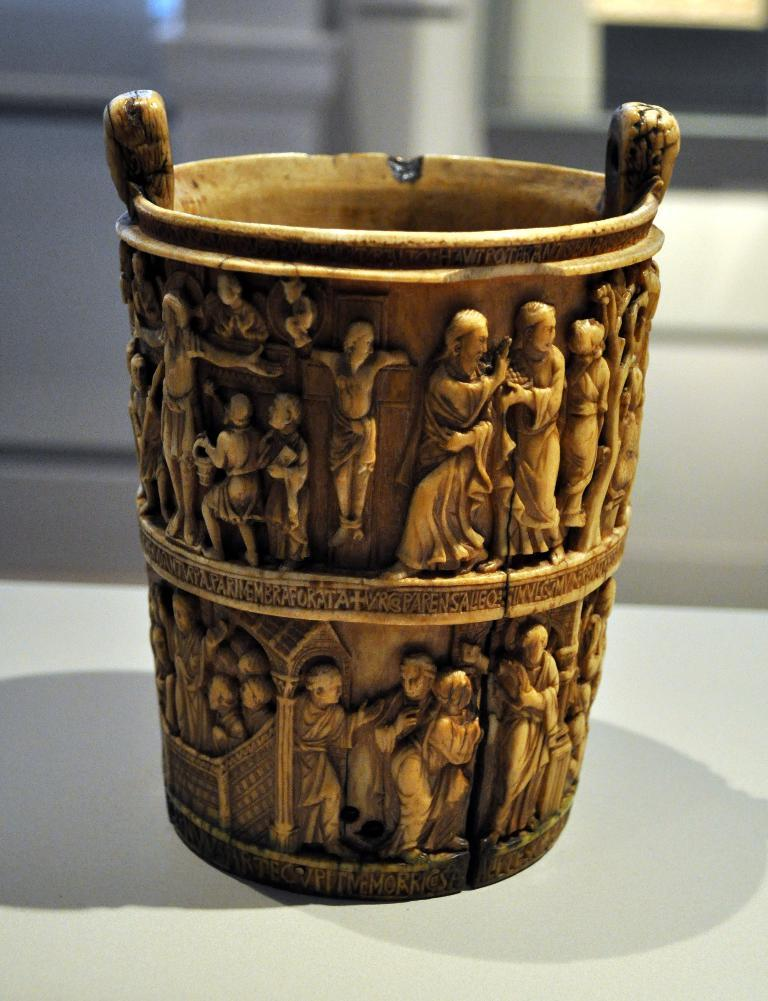What is the main object in the image? There is an object that looks like a cup in the image. What can be seen on the cup? The cup has sculptures on it. What architectural features are present in the image? There are pillars in the image. What type of creature is singing a song in the image? There is no creature or song present in the image. How many songs can be heard playing in the background of the image? There are no songs or background music in the image. 